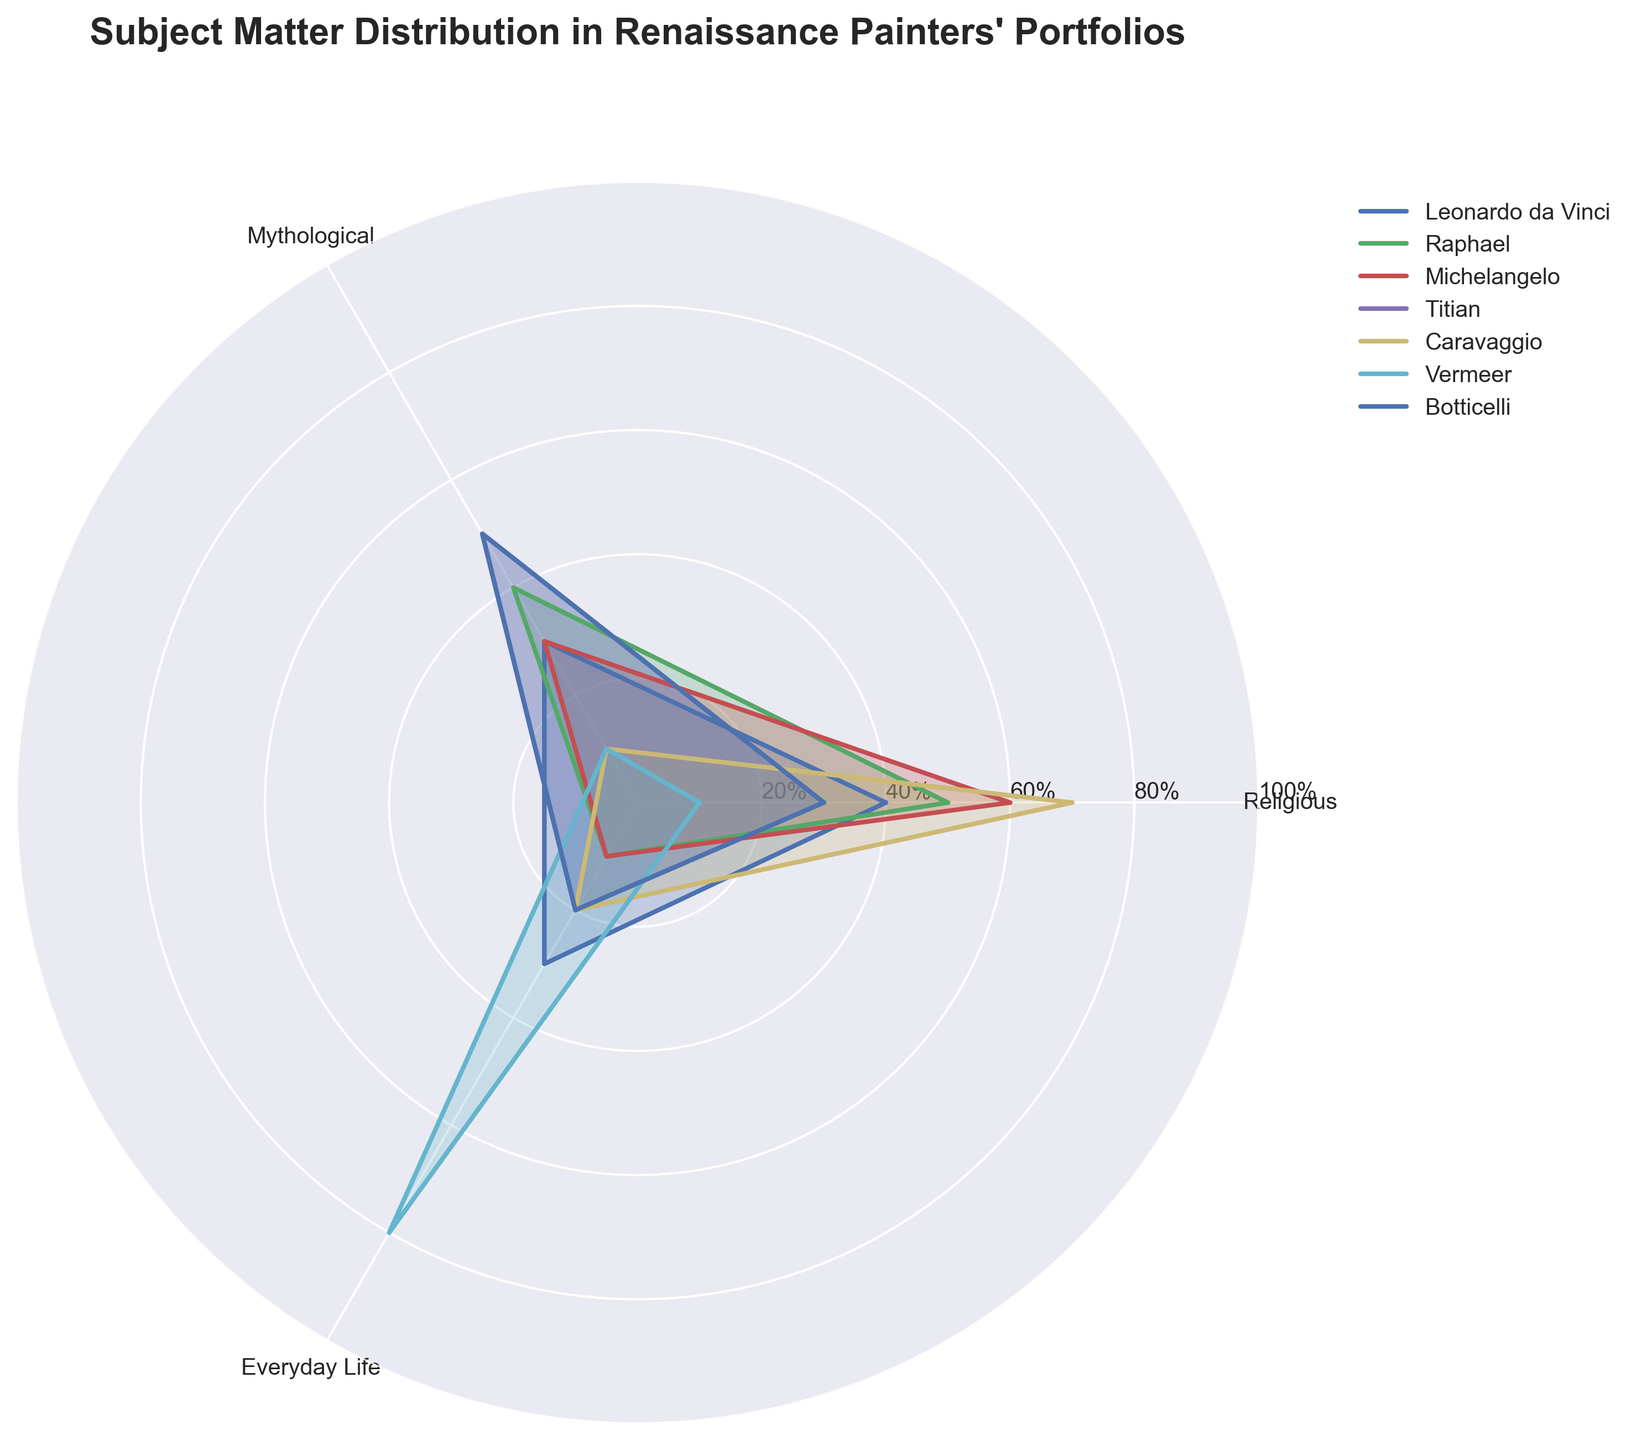What is the title of the chart? The title of the chart is typically found at the top, indicating the main subject of the visual representation.
Answer: Subject Matter Distribution in Renaissance Painters' Portfolios What are the subjects shown in the rose chart? The subjects are indicated by the category labels around the chart. The labels are "Religious," "Mythological," and "Everyday Life."
Answer: Religious, Mythological, Everyday Life Which painter has the highest proportion of religious subjects? By examining the radial lines, the painter with the largest value closest to the "Religious" label can be identified.
Answer: Caravaggio Among Leonardo da Vinci and Raphael, who depicted more mythological subjects? Compare the values along the radial lines nearest the "Mythological" label for both painters.
Answer: Raphael Which subject does Vermeer focus on the most? Observe the filled area or radial line for Vermeer, identify which subject is at the maximum value.
Answer: Everyday Life What is the combined percentage of mythological and everyday life subjects in Titian's portfolio? Sum the percentages of Mythological and Everyday Life subjects for Titian.
Answer: 70% How do the proportions of everyday life subjects compare between Michelangelo and Botticelli? Compare the values near the "Everyday Life" label for both painters. Both values are the same, reflecting 10% each.
Answer: Equal Who has the least focus on mythological subjects? Identify the painter with the smallest value near the "Mythological" label.
Answer: Caravaggio and Vermeer (tie) What is the difference in religious subject focus between Titian and Michelangelo? Subtract Titian's percentage from Michelangelo's percentage for the "Religious" subject.
Answer: 30% Which painter has the most balanced distribution across all three subjects? Identify the painter with the most even (closest) values for all three subject matters. Observationally, Leonardo da Vinci has the closest values for all three subjects.
Answer: Leonardo da Vinci 